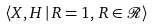<formula> <loc_0><loc_0><loc_500><loc_500>\langle X , H \, | \, R = 1 , \, R \in \mathcal { R } \rangle</formula> 